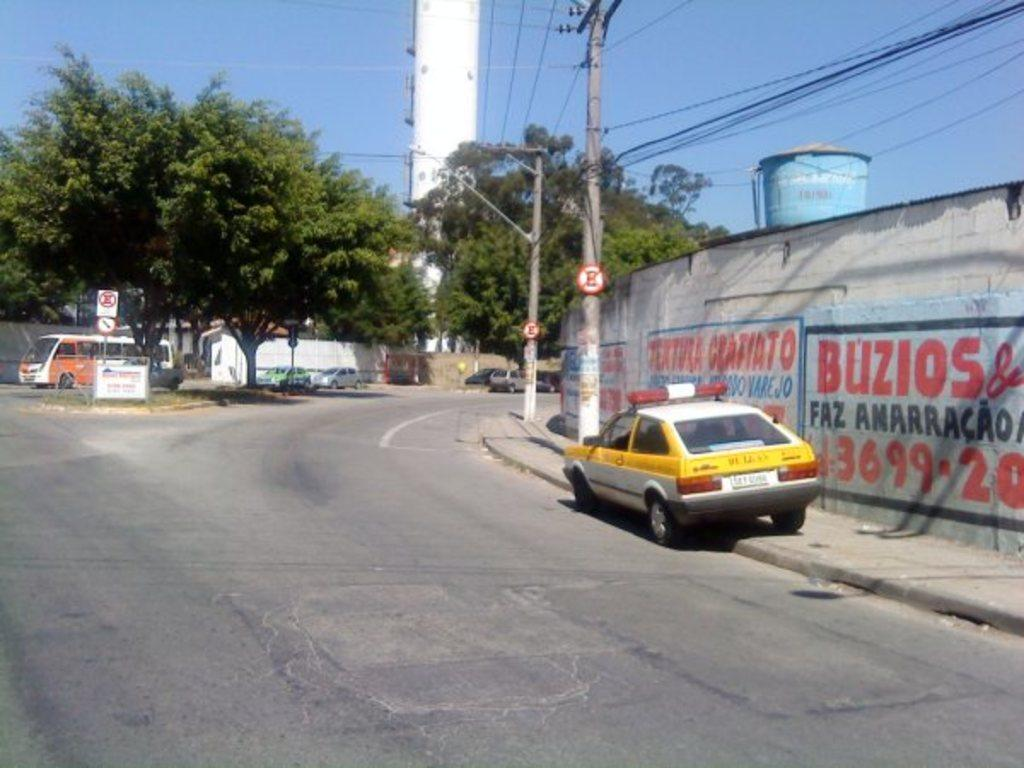<image>
Offer a succinct explanation of the picture presented. A white and yellow car park on the side near a wall with Buzios on it. 